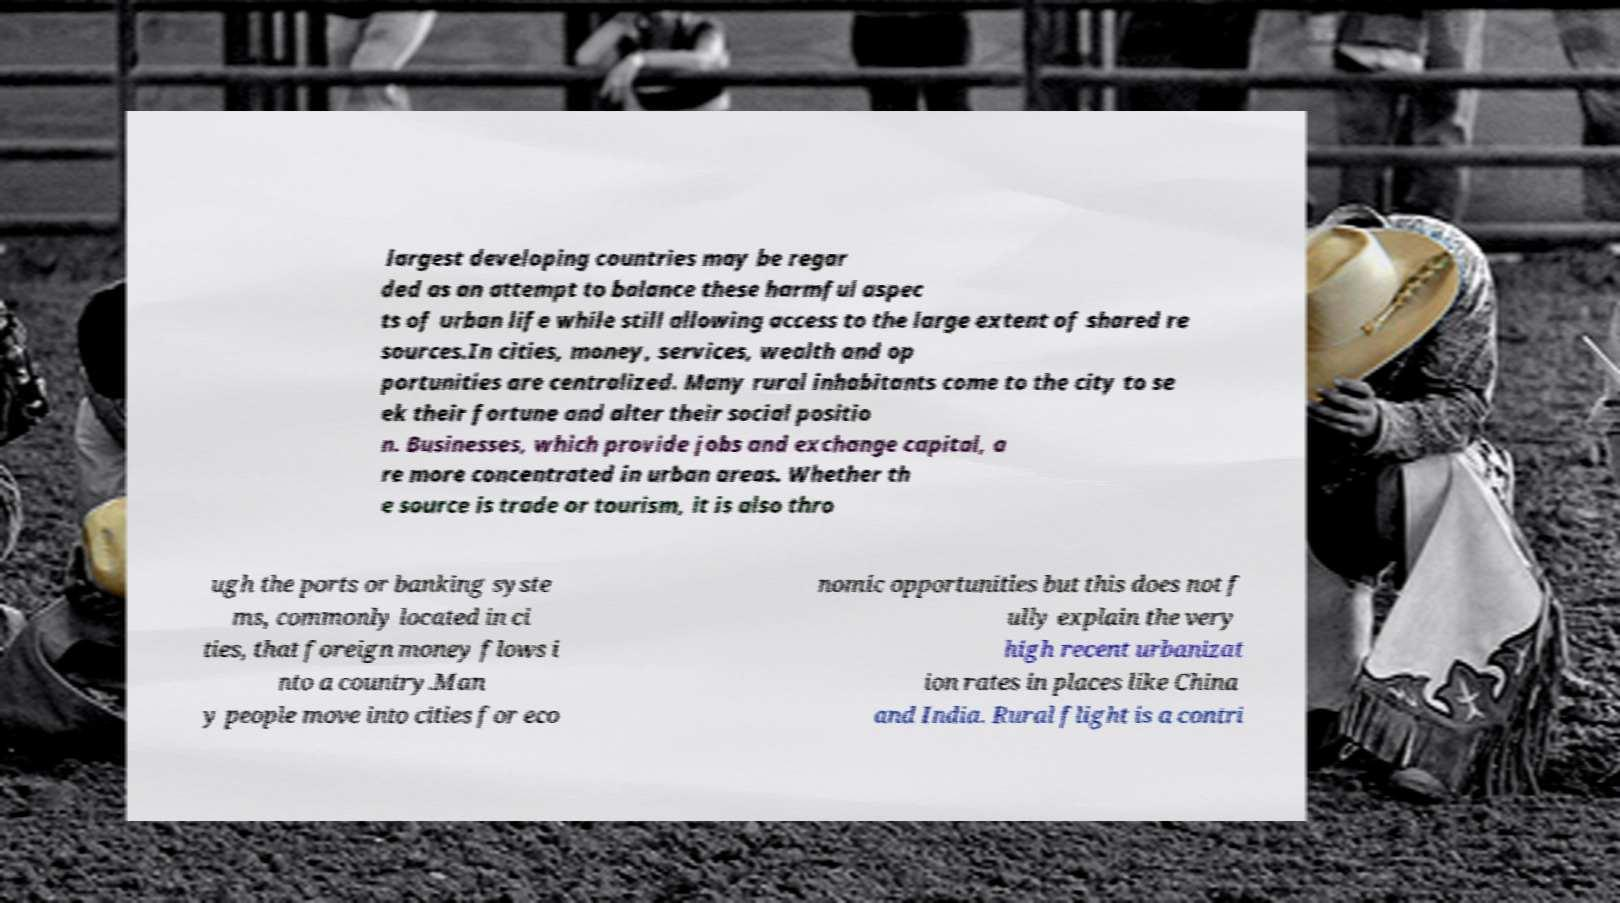Please identify and transcribe the text found in this image. largest developing countries may be regar ded as an attempt to balance these harmful aspec ts of urban life while still allowing access to the large extent of shared re sources.In cities, money, services, wealth and op portunities are centralized. Many rural inhabitants come to the city to se ek their fortune and alter their social positio n. Businesses, which provide jobs and exchange capital, a re more concentrated in urban areas. Whether th e source is trade or tourism, it is also thro ugh the ports or banking syste ms, commonly located in ci ties, that foreign money flows i nto a country.Man y people move into cities for eco nomic opportunities but this does not f ully explain the very high recent urbanizat ion rates in places like China and India. Rural flight is a contri 